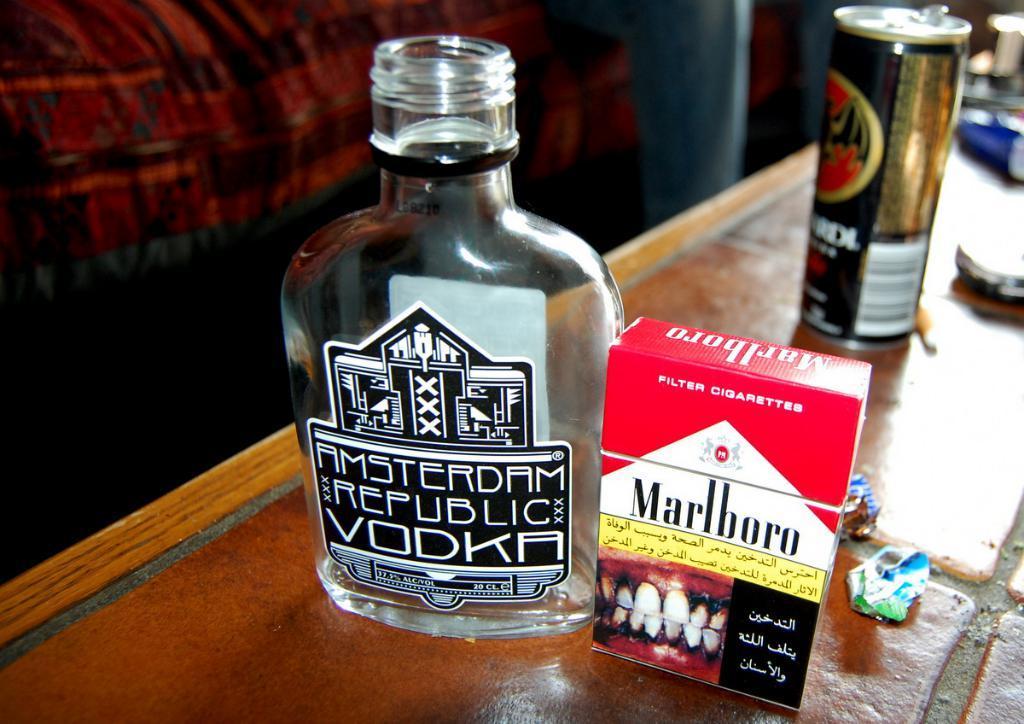Describe this image in one or two sentences. There is a bottle, box, tin and some other items on a table. In the background, there is a red color cloth. 